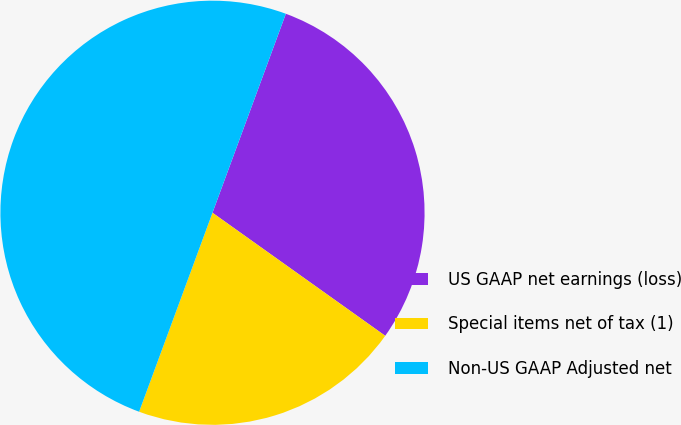Convert chart. <chart><loc_0><loc_0><loc_500><loc_500><pie_chart><fcel>US GAAP net earnings (loss)<fcel>Special items net of tax (1)<fcel>Non-US GAAP Adjusted net<nl><fcel>29.23%<fcel>20.77%<fcel>50.0%<nl></chart> 